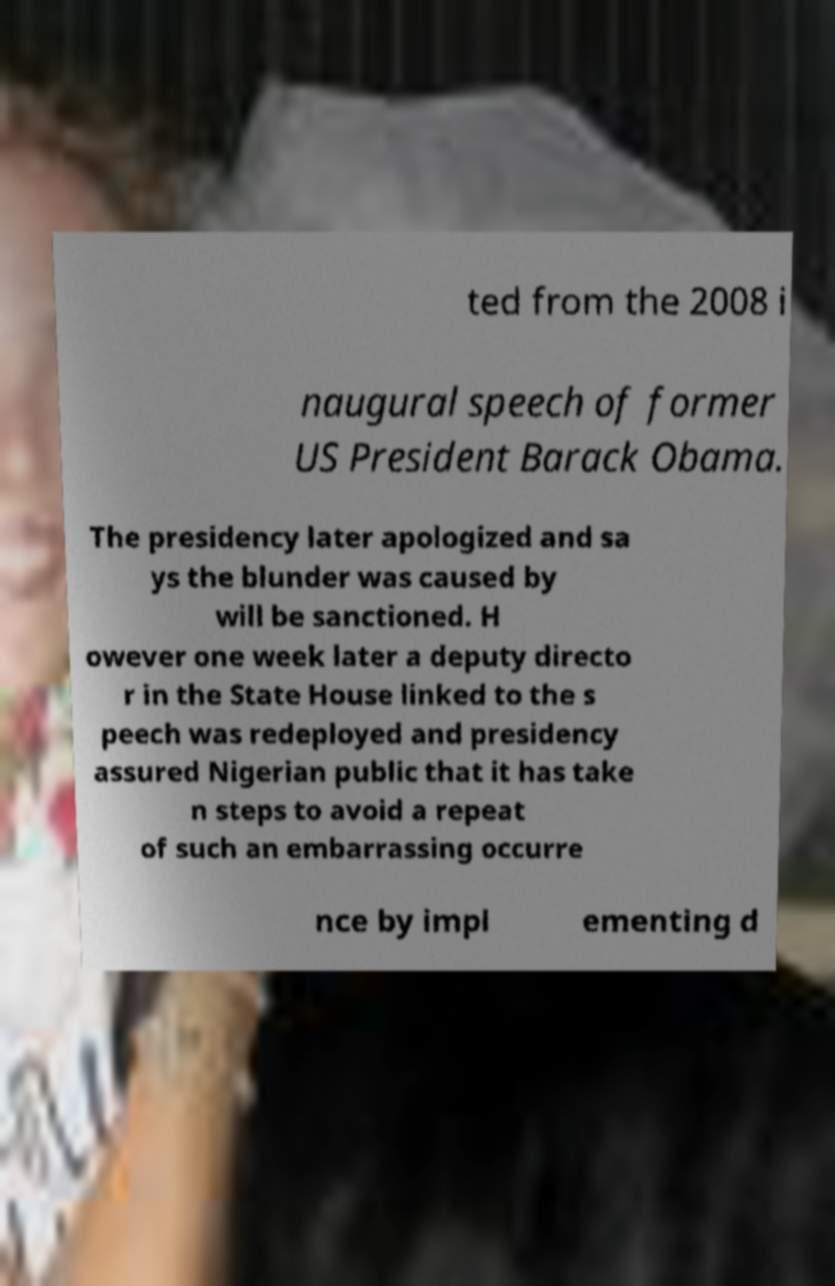Can you accurately transcribe the text from the provided image for me? ted from the 2008 i naugural speech of former US President Barack Obama. The presidency later apologized and sa ys the blunder was caused by will be sanctioned. H owever one week later a deputy directo r in the State House linked to the s peech was redeployed and presidency assured Nigerian public that it has take n steps to avoid a repeat of such an embarrassing occurre nce by impl ementing d 